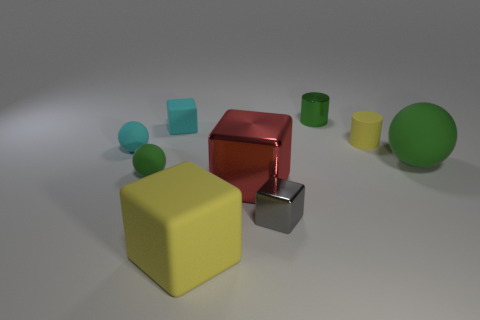How many green balls must be subtracted to get 1 green balls? 1 Subtract all spheres. How many objects are left? 6 Subtract all green cylinders. How many cylinders are left? 1 Subtract all green rubber balls. How many balls are left? 1 Subtract 2 cylinders. How many cylinders are left? 0 Subtract all blue balls. Subtract all yellow cylinders. How many balls are left? 3 Subtract all yellow spheres. How many yellow cylinders are left? 1 Subtract all tiny green matte objects. Subtract all tiny green things. How many objects are left? 6 Add 3 yellow matte cylinders. How many yellow matte cylinders are left? 4 Add 4 big red metal objects. How many big red metal objects exist? 5 